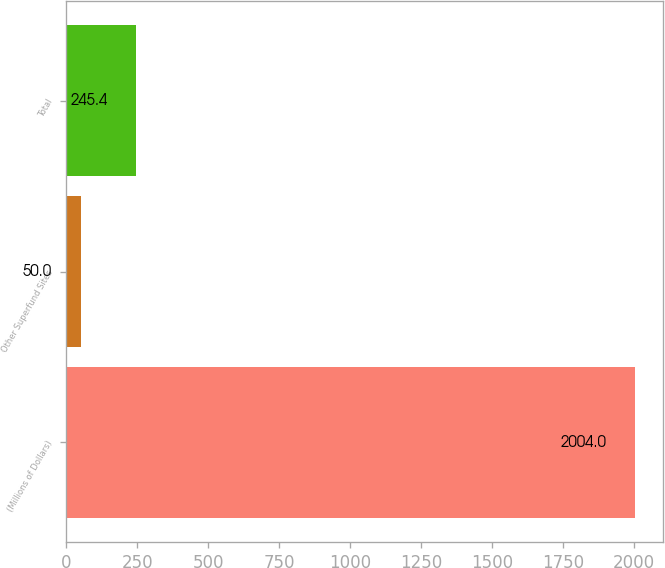Convert chart to OTSL. <chart><loc_0><loc_0><loc_500><loc_500><bar_chart><fcel>(Millions of Dollars)<fcel>Other Superfund Sites<fcel>Total<nl><fcel>2004<fcel>50<fcel>245.4<nl></chart> 